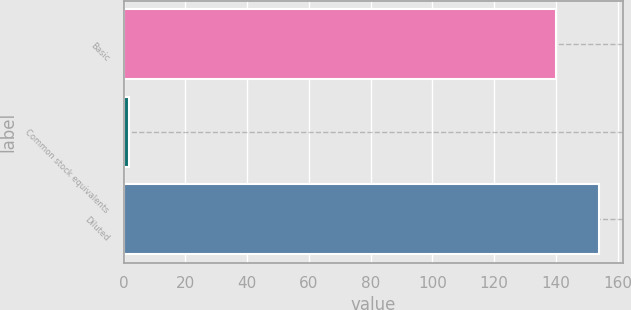Convert chart. <chart><loc_0><loc_0><loc_500><loc_500><bar_chart><fcel>Basic<fcel>Common stock equivalents<fcel>Diluted<nl><fcel>140<fcel>1.6<fcel>154<nl></chart> 